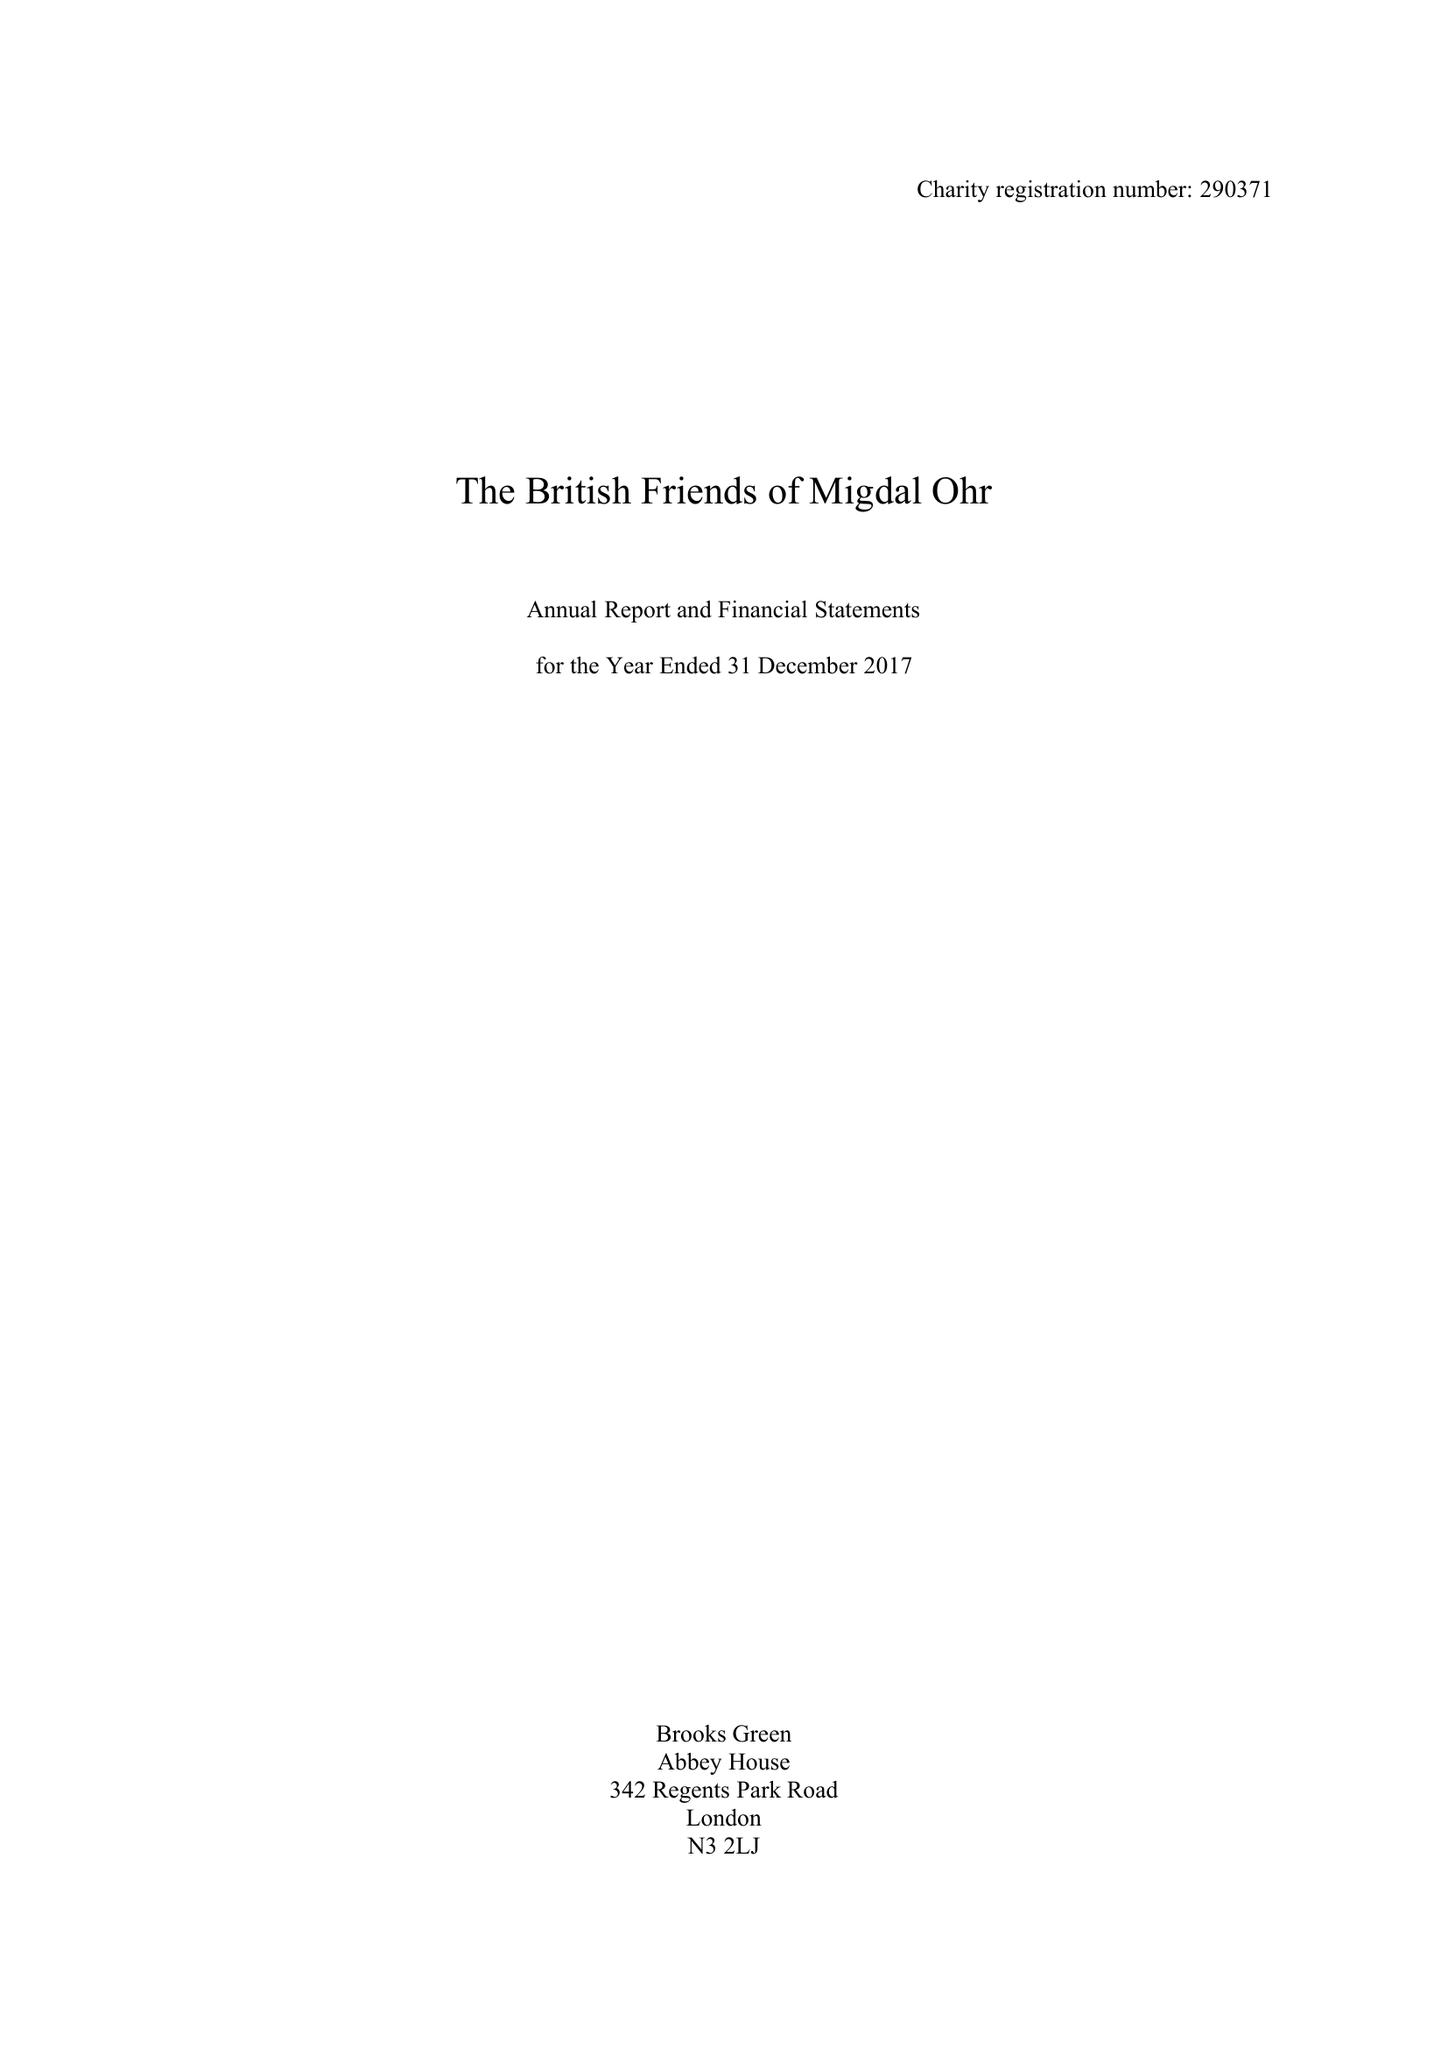What is the value for the address__postcode?
Answer the question using a single word or phrase. W1H 6EG 